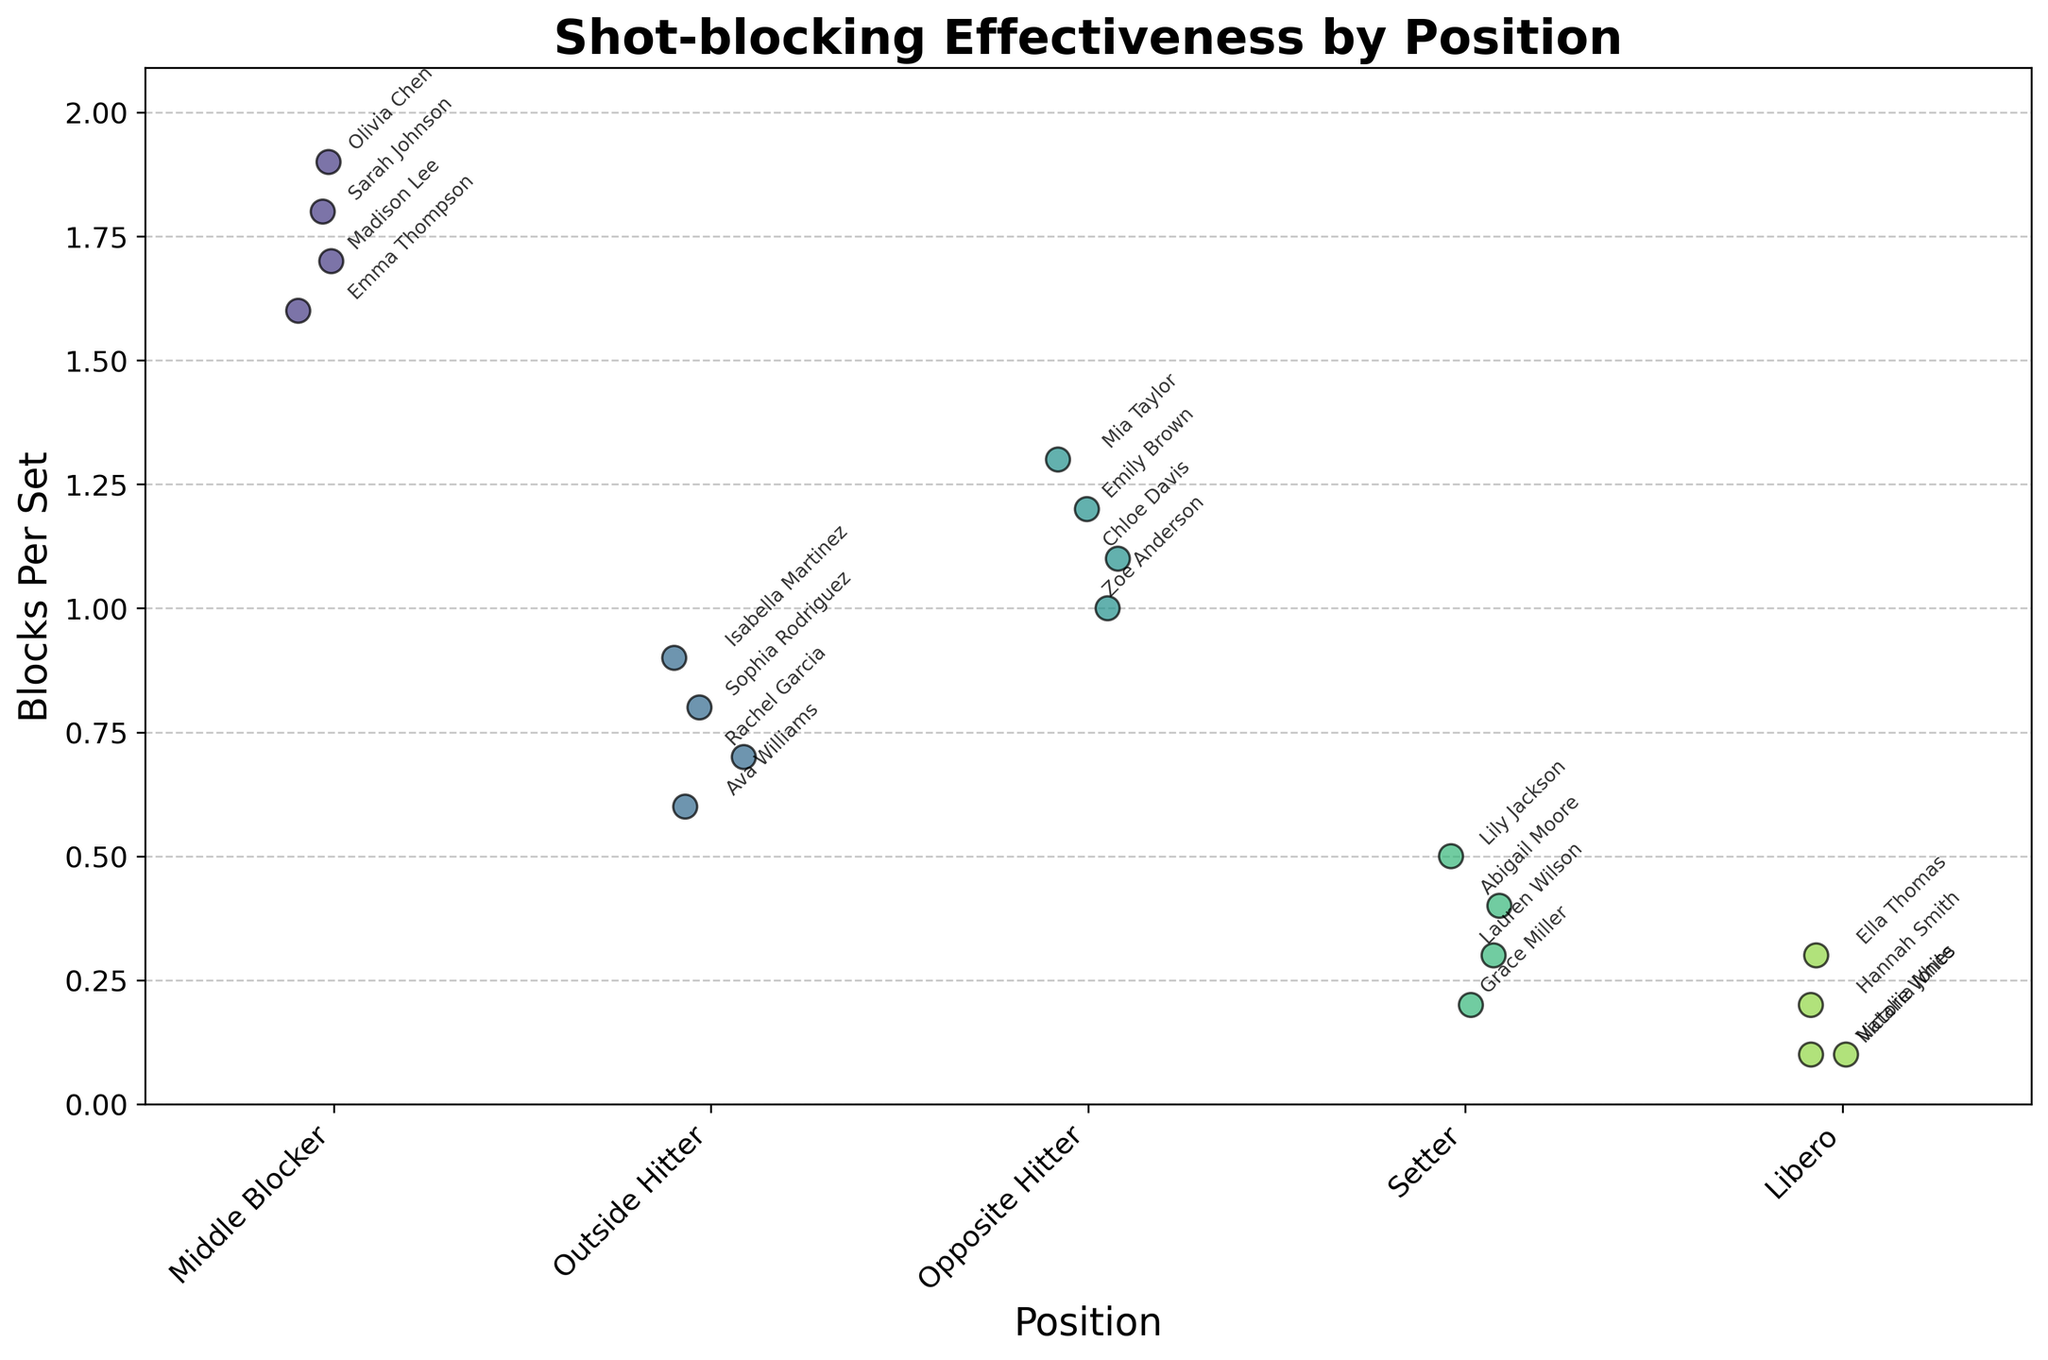What is the overall title of the plot? The overall title is usually located at the top of the plot and gives a summary of the content.
Answer: Shot-blocking Effectiveness by Position What is the highest Blocks Per Set value depicted in the plot? To find the highest value, look at the y-axis to find the uppermost point. The highest block per set value is 1.9.
Answer: 1.9 Which position shows the highest variability in the blocks per set? To determine variability, observe the spread of the points for each position. Middle Blocker shows the highest spread, from 1.6 to 1.9.
Answer: Middle Blocker How many players are positioned as Libero in the plot? Count the number of data points under the Libero category on the x-axis.
Answer: 4 Is there a direct relationship between player position and blocks per set? Observing the arrangement, there appears to be a relationship where Middle Blockers and Opposite Hitters generally have higher blocking rates than Setters and Libero.
Answer: Yes, there is a relationship What is the median value for the blocks per set among Middle Blockers? To find the median, list the Middle Blocker values (1.6, 1.7, 1.8, 1.9) and find the middle value. With an even number of data points, the median is the average of the two middle numbers (1.7 and 1.8), which is 1.75.
Answer: 1.75 Between Middle Blocker and Outside Hitter, which position has players with a more consistent block rate? Observing the plot, the spread of blocks per set for Middle Blockers (1.6-1.9) is tighter compared to Outside Hitters (0.6-0.9).
Answer: Middle Blocker Which player has the highest blocks per set among all positions? Look for the highest point in the entire plot and identify the label. The highest value, 1.9, corresponds to Olivia Chen from the Middle Blocker position.
Answer: Olivia Chen What is the average blocks per set for Setters? Add the blocks per set values for Setters (0.2, 0.3, 0.4, 0.5) and divide by the number of Setters. The calculation is (0.2 + 0.3 + 0.4 + 0.5) / 4 = 1.4 / 4 = 0.35.
Answer: 0.35 